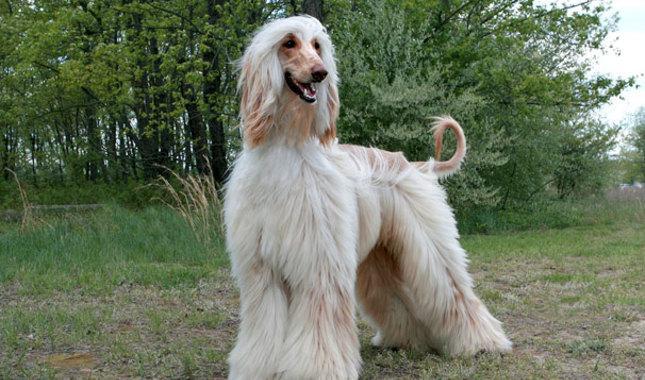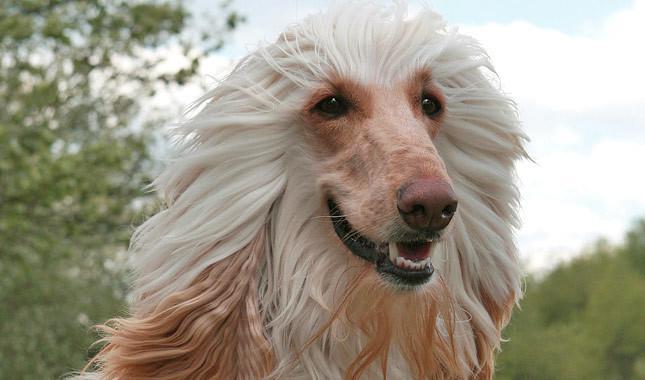The first image is the image on the left, the second image is the image on the right. Given the left and right images, does the statement "The dog in the image on the left is outside." hold true? Answer yes or no. Yes. The first image is the image on the left, the second image is the image on the right. For the images shown, is this caption "The hound on the left is more golden brown, and the one on the right is more cream colored." true? Answer yes or no. No. The first image is the image on the left, the second image is the image on the right. For the images shown, is this caption "Only the dogs head can be seen in the image on the right." true? Answer yes or no. Yes. 